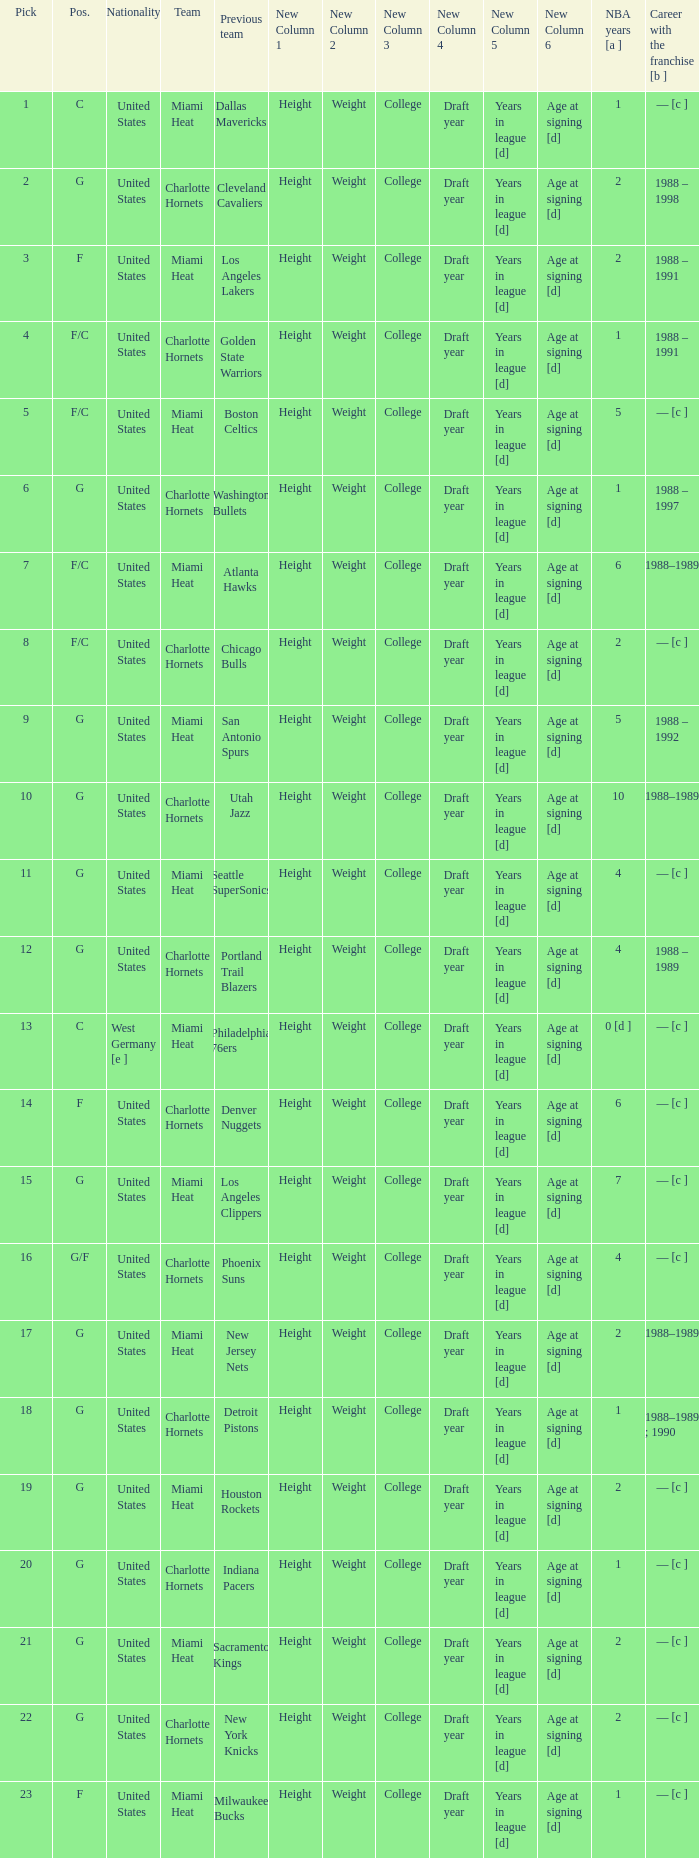What is the team of the player who was previously on the indiana pacers? Charlotte Hornets. 